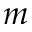Convert formula to latex. <formula><loc_0><loc_0><loc_500><loc_500>m</formula> 